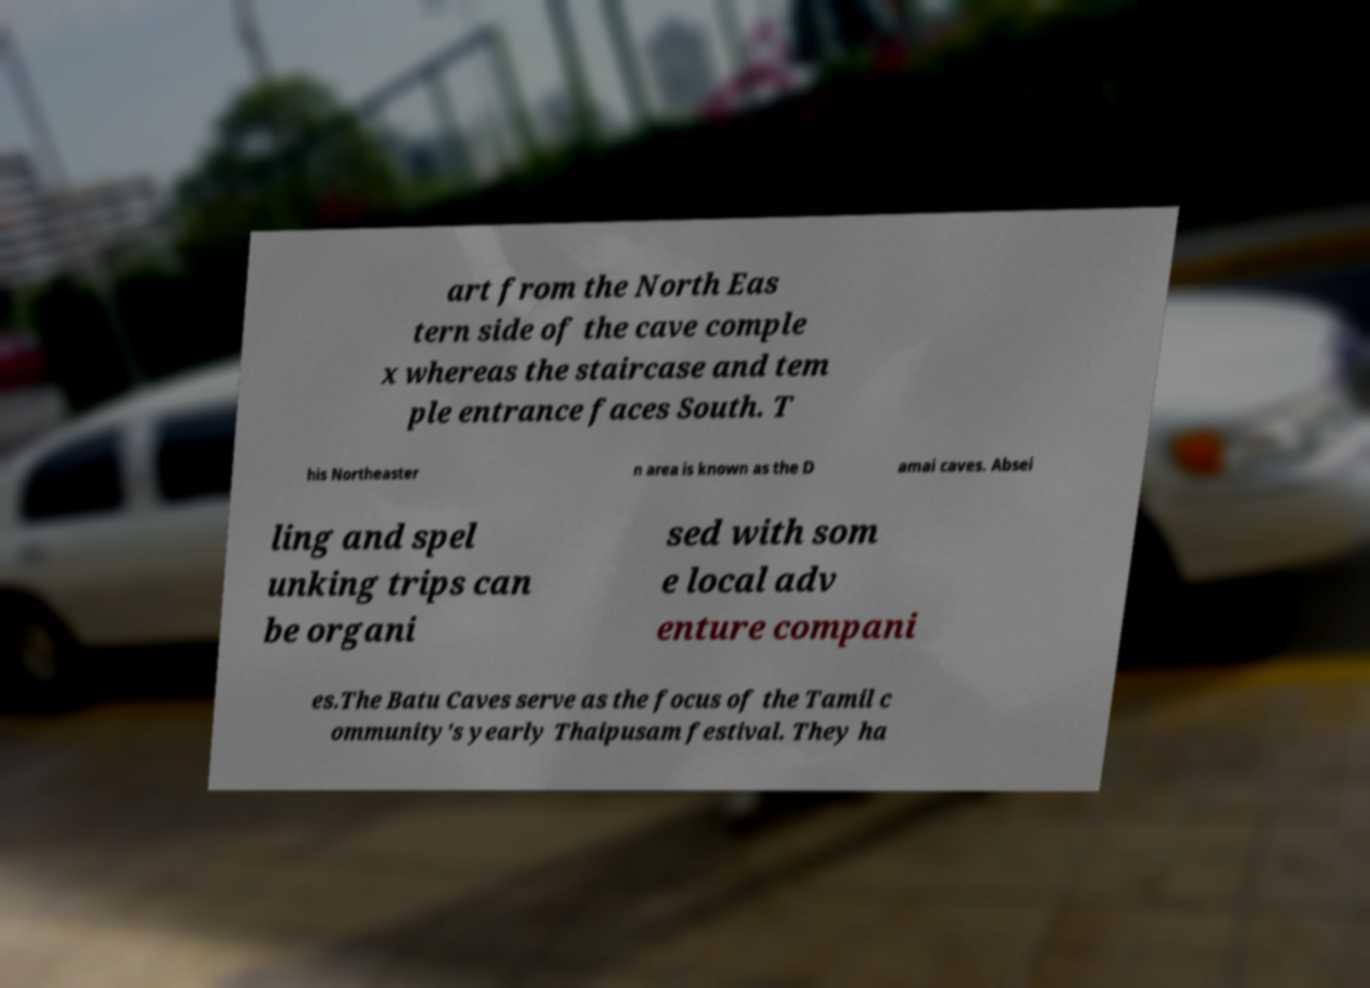I need the written content from this picture converted into text. Can you do that? art from the North Eas tern side of the cave comple x whereas the staircase and tem ple entrance faces South. T his Northeaster n area is known as the D amai caves. Absei ling and spel unking trips can be organi sed with som e local adv enture compani es.The Batu Caves serve as the focus of the Tamil c ommunity's yearly Thaipusam festival. They ha 